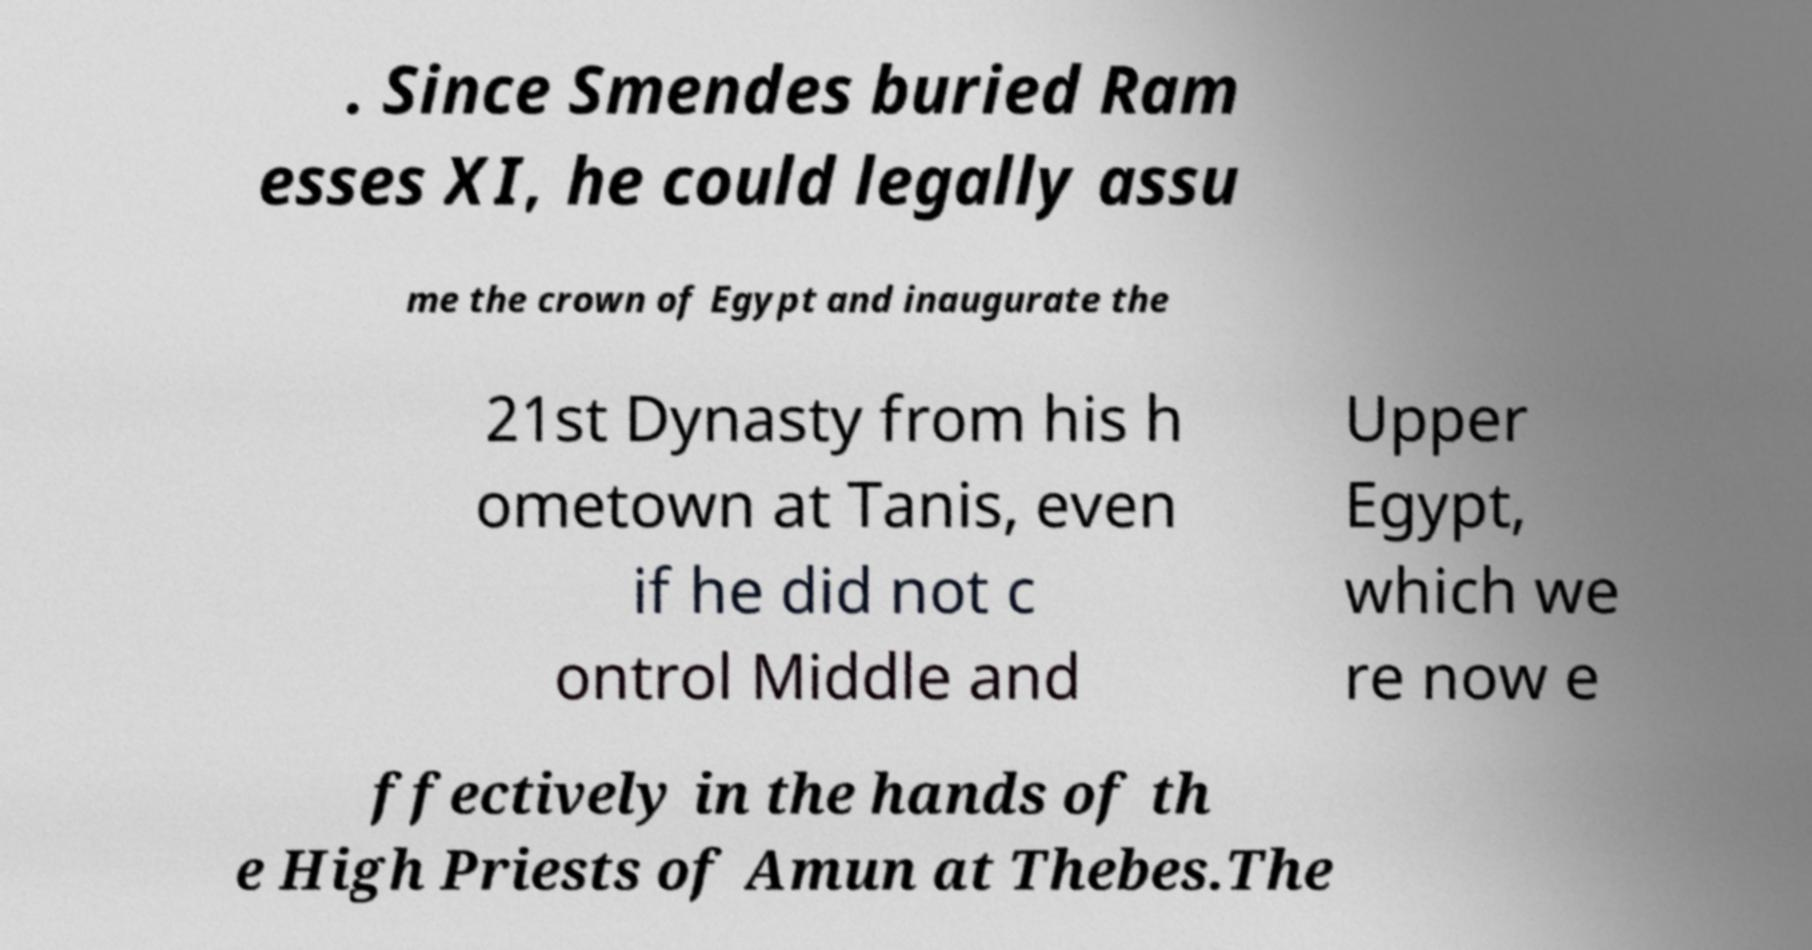Can you read and provide the text displayed in the image?This photo seems to have some interesting text. Can you extract and type it out for me? . Since Smendes buried Ram esses XI, he could legally assu me the crown of Egypt and inaugurate the 21st Dynasty from his h ometown at Tanis, even if he did not c ontrol Middle and Upper Egypt, which we re now e ffectively in the hands of th e High Priests of Amun at Thebes.The 